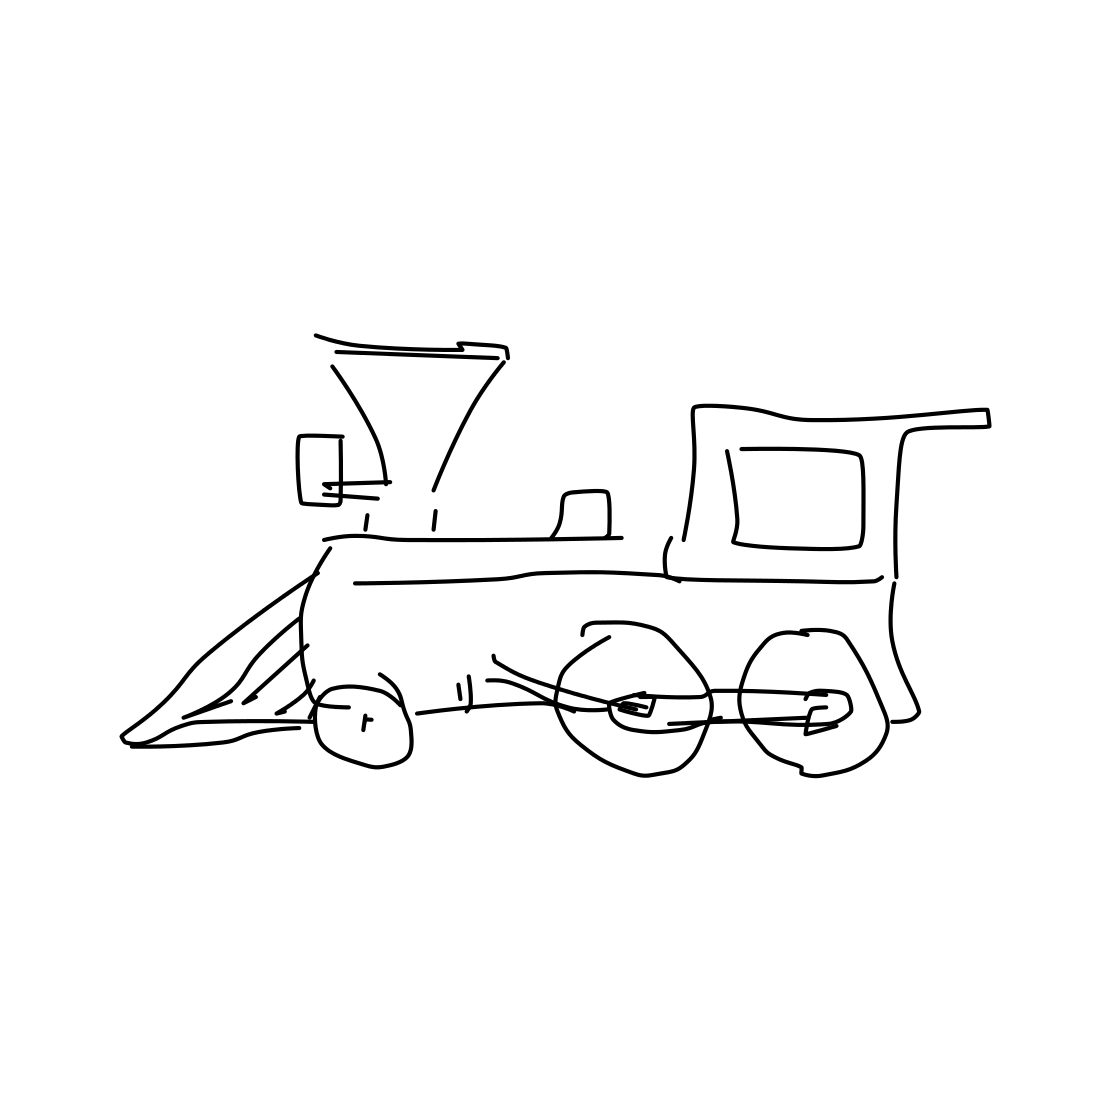Imagine this train is part of a story. What kind of setting do you think it would fit in? This train would perfectly fit a historical or steampunk narrative, chugging along through the expansive landscapes of the American West or involved in industrial espionage in an alternate Victorian era where steam technology advanced in unique ways. 